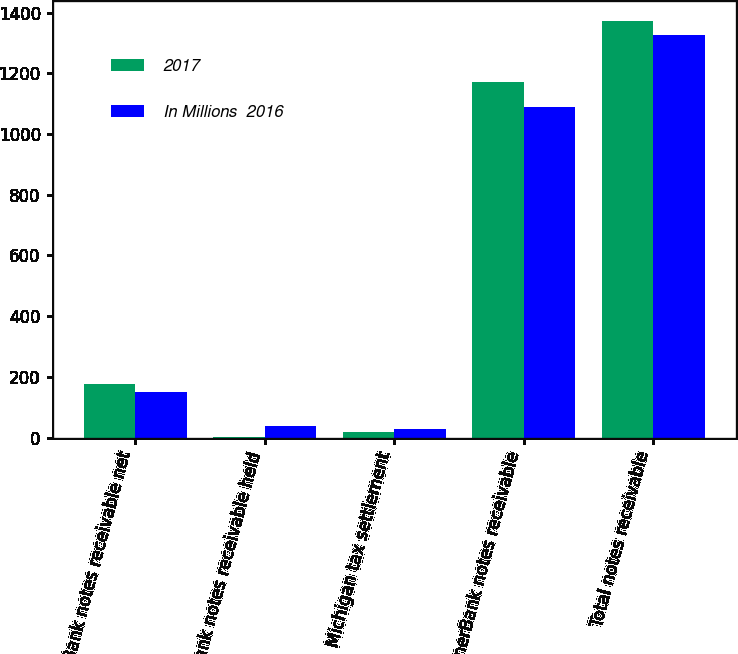Convert chart to OTSL. <chart><loc_0><loc_0><loc_500><loc_500><stacked_bar_chart><ecel><fcel>EnerBank notes receivable net<fcel>EnerBank notes receivable held<fcel>Michigan tax settlement<fcel>EnerBank notes receivable<fcel>Total notes receivable<nl><fcel>2017<fcel>178<fcel>2<fcel>20<fcel>1171<fcel>1371<nl><fcel>In Millions  2016<fcel>151<fcel>39<fcel>29<fcel>1088<fcel>1326<nl></chart> 